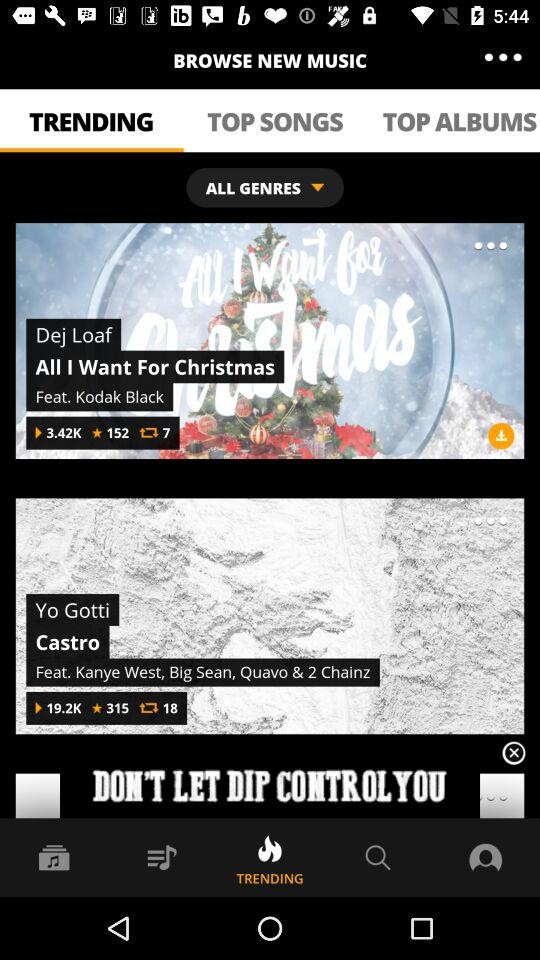How many favorites are there for "All I Want For Christmas"? There are 152 favorites for "All I Want For Christmas". 